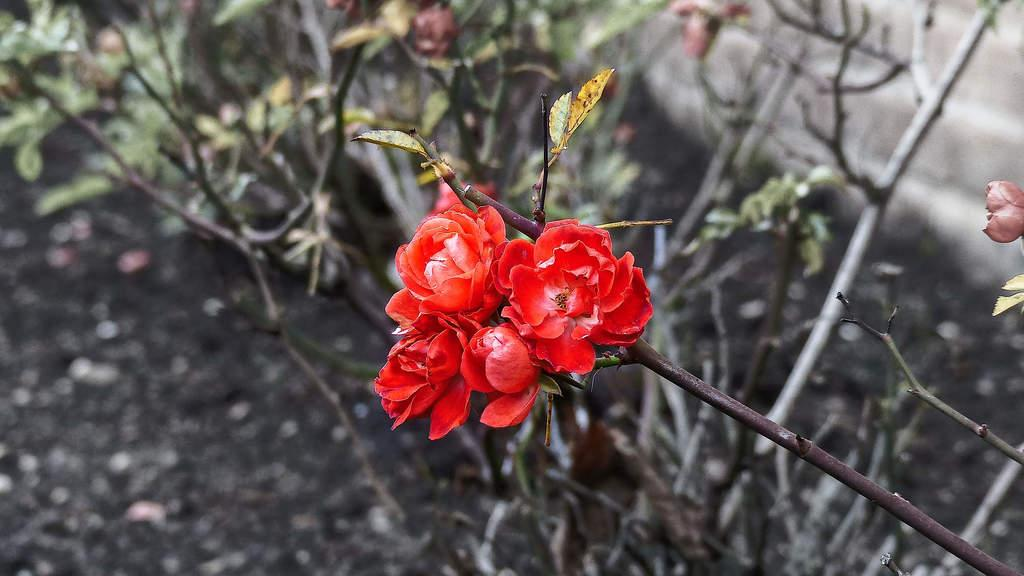Where was the picture taken? The picture was clicked outside. What is the main subject in the center of the image? There is a plant with flowers and leaves in the center of the image. What can be seen in the background of the image? There are plants, leaves, and flowers visible in the background of the image. Can you describe any other objects in the background? There are other unspecified objects in the background of the image. How does the bed look like in the image? There is no bed present in the image; it was taken outside and features a plant with flowers and leaves in the center. 